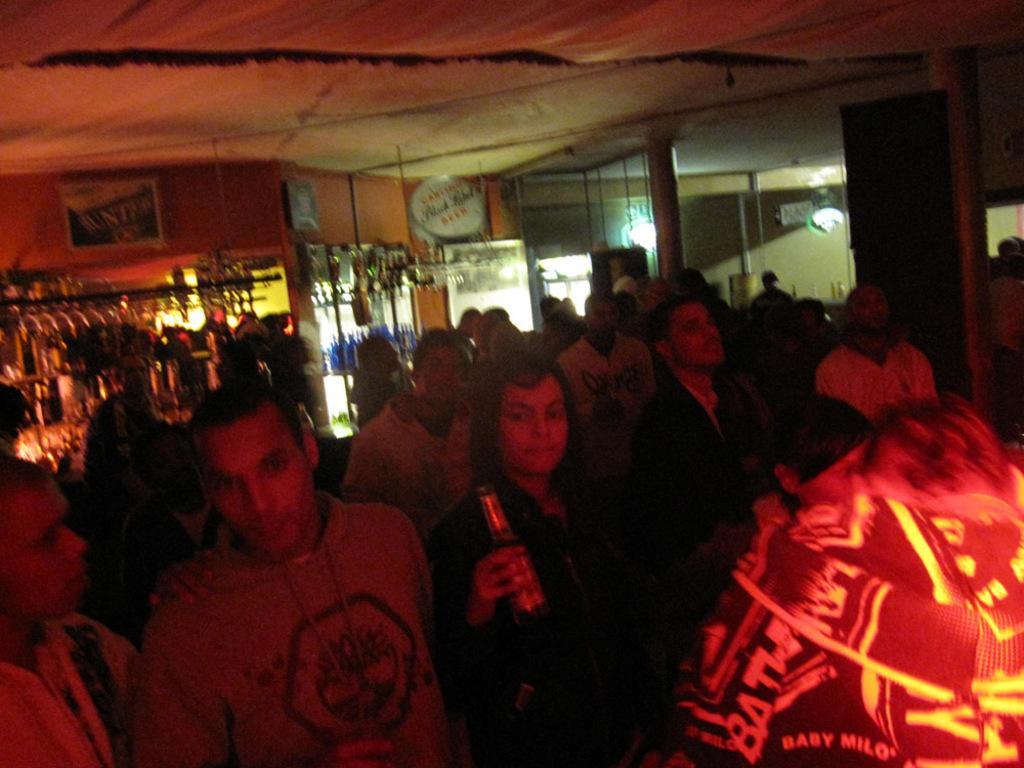Describe this image in one or two sentences. In the center of the image a group of people are there and a lady is holding a bottle. In the background of the image we can see some objects, boards, wall, pillars, lights. At the top of the image there is a roof. 